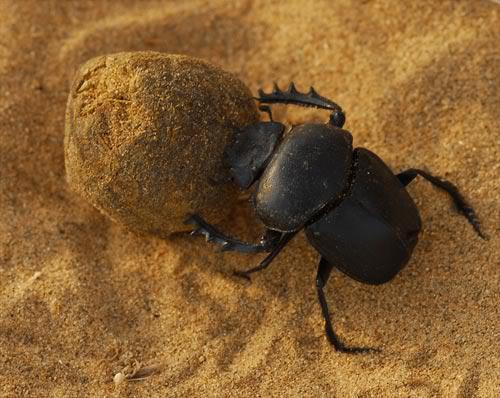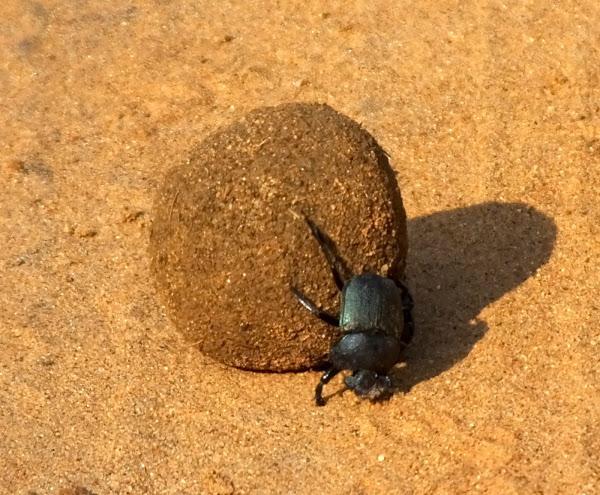The first image is the image on the left, the second image is the image on the right. Examine the images to the left and right. Is the description "Each image includes at least one beetle in contact with a brown ball." accurate? Answer yes or no. Yes. The first image is the image on the left, the second image is the image on the right. Considering the images on both sides, is "One of the dung beetles is not near a ball of dung." valid? Answer yes or no. No. 